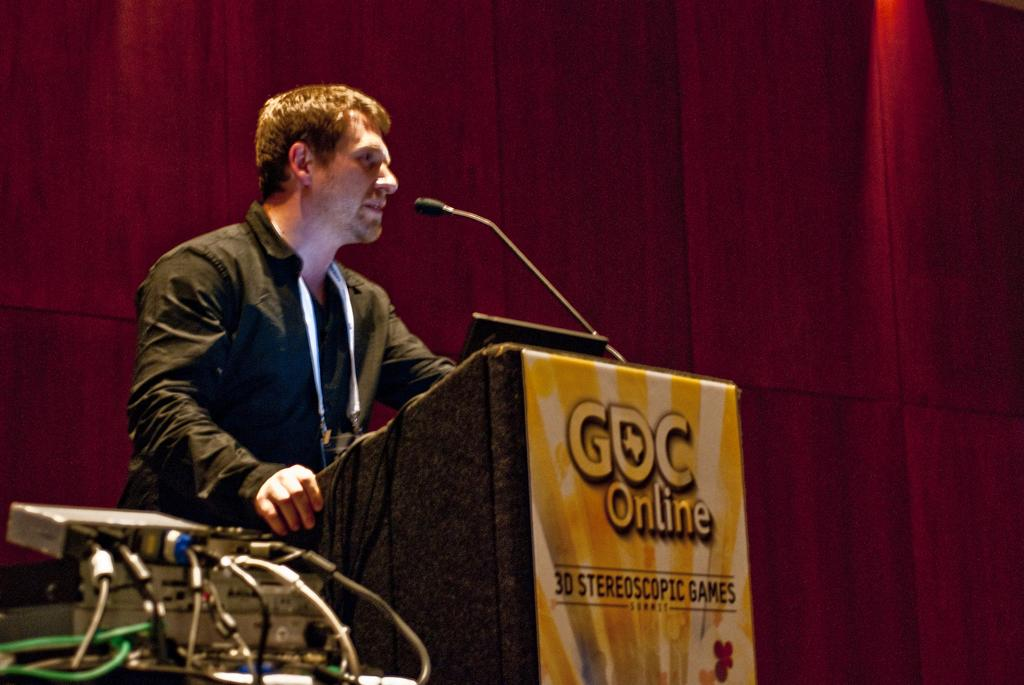Provide a one-sentence caption for the provided image. A speaker at a podium is talking about stereoscopic games. 